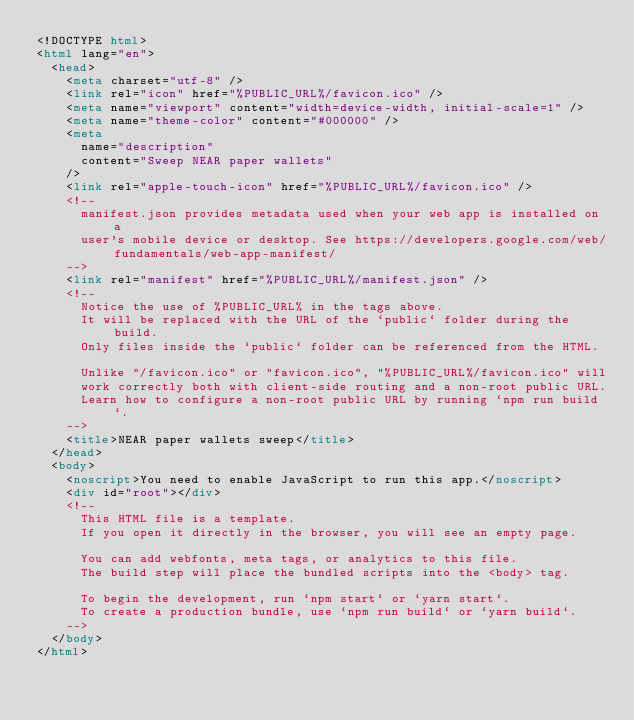Convert code to text. <code><loc_0><loc_0><loc_500><loc_500><_HTML_><!DOCTYPE html>
<html lang="en">
  <head>
    <meta charset="utf-8" />
    <link rel="icon" href="%PUBLIC_URL%/favicon.ico" />
    <meta name="viewport" content="width=device-width, initial-scale=1" />
    <meta name="theme-color" content="#000000" />
    <meta
      name="description"
      content="Sweep NEAR paper wallets"
    />
    <link rel="apple-touch-icon" href="%PUBLIC_URL%/favicon.ico" />
    <!--
      manifest.json provides metadata used when your web app is installed on a
      user's mobile device or desktop. See https://developers.google.com/web/fundamentals/web-app-manifest/
    -->
    <link rel="manifest" href="%PUBLIC_URL%/manifest.json" />
    <!--
      Notice the use of %PUBLIC_URL% in the tags above.
      It will be replaced with the URL of the `public` folder during the build.
      Only files inside the `public` folder can be referenced from the HTML.

      Unlike "/favicon.ico" or "favicon.ico", "%PUBLIC_URL%/favicon.ico" will
      work correctly both with client-side routing and a non-root public URL.
      Learn how to configure a non-root public URL by running `npm run build`.
    -->
    <title>NEAR paper wallets sweep</title>
  </head>
  <body>
    <noscript>You need to enable JavaScript to run this app.</noscript>
    <div id="root"></div>
    <!--
      This HTML file is a template.
      If you open it directly in the browser, you will see an empty page.

      You can add webfonts, meta tags, or analytics to this file.
      The build step will place the bundled scripts into the <body> tag.

      To begin the development, run `npm start` or `yarn start`.
      To create a production bundle, use `npm run build` or `yarn build`.
    -->
  </body>
</html>
</code> 